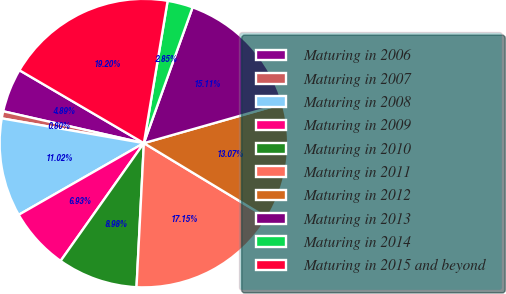Convert chart to OTSL. <chart><loc_0><loc_0><loc_500><loc_500><pie_chart><fcel>Maturing in 2006<fcel>Maturing in 2007<fcel>Maturing in 2008<fcel>Maturing in 2009<fcel>Maturing in 2010<fcel>Maturing in 2011<fcel>Maturing in 2012<fcel>Maturing in 2013<fcel>Maturing in 2014<fcel>Maturing in 2015 and beyond<nl><fcel>4.89%<fcel>0.8%<fcel>11.02%<fcel>6.93%<fcel>8.98%<fcel>17.15%<fcel>13.07%<fcel>15.11%<fcel>2.85%<fcel>19.2%<nl></chart> 